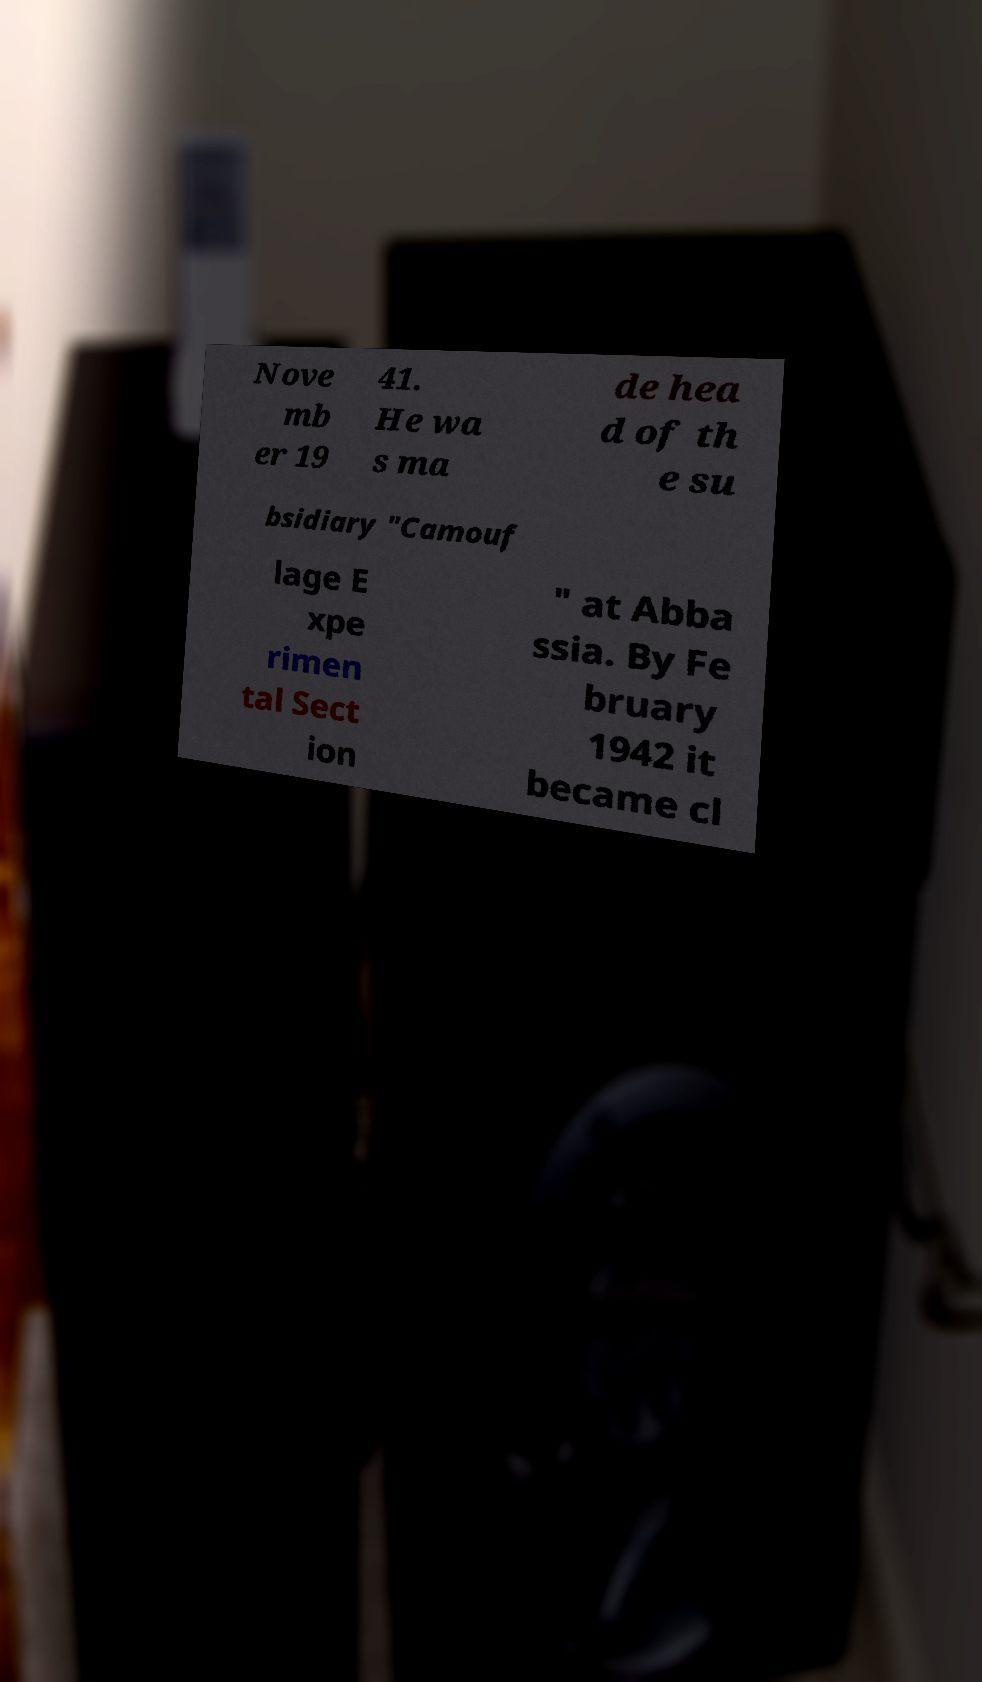Could you assist in decoding the text presented in this image and type it out clearly? Nove mb er 19 41. He wa s ma de hea d of th e su bsidiary "Camouf lage E xpe rimen tal Sect ion " at Abba ssia. By Fe bruary 1942 it became cl 